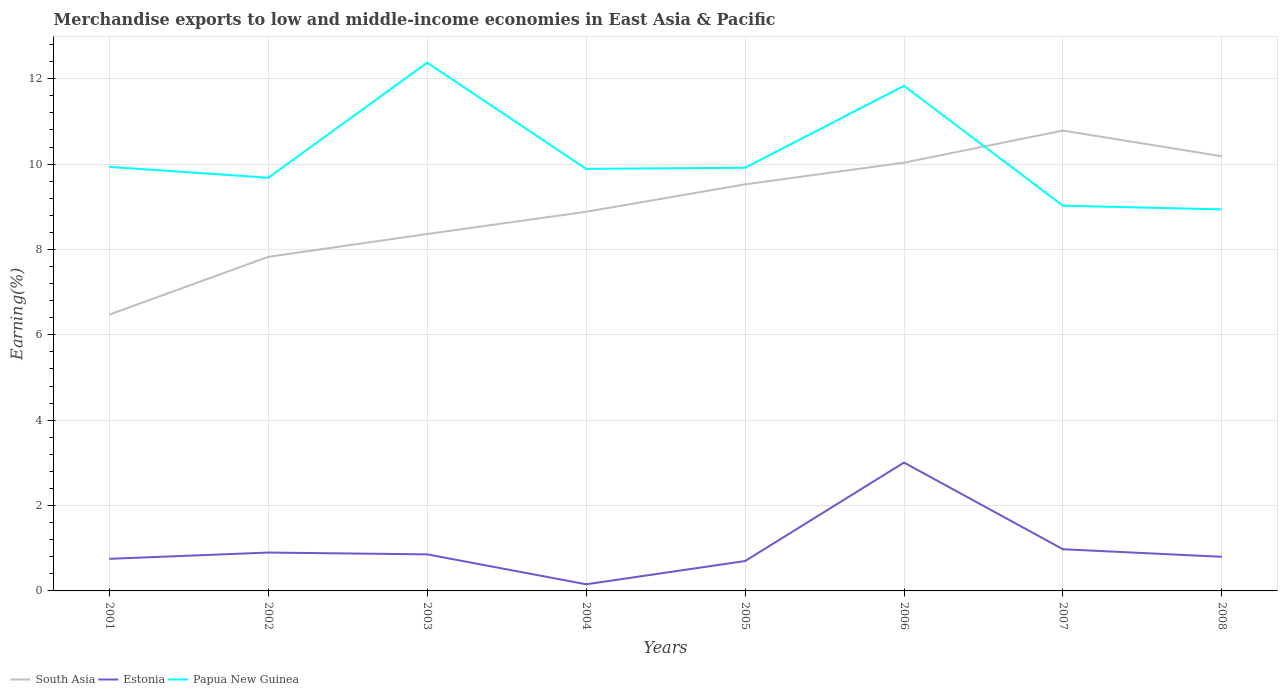Does the line corresponding to Estonia intersect with the line corresponding to South Asia?
Ensure brevity in your answer.  No. Is the number of lines equal to the number of legend labels?
Your answer should be compact. Yes. Across all years, what is the maximum percentage of amount earned from merchandise exports in South Asia?
Your answer should be very brief. 6.47. In which year was the percentage of amount earned from merchandise exports in Estonia maximum?
Your answer should be very brief. 2004. What is the total percentage of amount earned from merchandise exports in South Asia in the graph?
Give a very brief answer. -2.42. What is the difference between the highest and the second highest percentage of amount earned from merchandise exports in Papua New Guinea?
Your answer should be compact. 3.44. Is the percentage of amount earned from merchandise exports in Estonia strictly greater than the percentage of amount earned from merchandise exports in Papua New Guinea over the years?
Keep it short and to the point. Yes. How many lines are there?
Offer a very short reply. 3. Does the graph contain any zero values?
Provide a short and direct response. No. Does the graph contain grids?
Provide a succinct answer. Yes. Where does the legend appear in the graph?
Keep it short and to the point. Bottom left. How are the legend labels stacked?
Ensure brevity in your answer.  Horizontal. What is the title of the graph?
Offer a very short reply. Merchandise exports to low and middle-income economies in East Asia & Pacific. What is the label or title of the Y-axis?
Keep it short and to the point. Earning(%). What is the Earning(%) in South Asia in 2001?
Provide a short and direct response. 6.47. What is the Earning(%) in Estonia in 2001?
Give a very brief answer. 0.75. What is the Earning(%) of Papua New Guinea in 2001?
Provide a short and direct response. 9.94. What is the Earning(%) in South Asia in 2002?
Offer a very short reply. 7.83. What is the Earning(%) in Estonia in 2002?
Your response must be concise. 0.9. What is the Earning(%) in Papua New Guinea in 2002?
Your answer should be compact. 9.68. What is the Earning(%) of South Asia in 2003?
Your response must be concise. 8.36. What is the Earning(%) in Estonia in 2003?
Keep it short and to the point. 0.86. What is the Earning(%) in Papua New Guinea in 2003?
Make the answer very short. 12.38. What is the Earning(%) in South Asia in 2004?
Your answer should be very brief. 8.88. What is the Earning(%) in Estonia in 2004?
Offer a very short reply. 0.16. What is the Earning(%) of Papua New Guinea in 2004?
Keep it short and to the point. 9.89. What is the Earning(%) in South Asia in 2005?
Give a very brief answer. 9.53. What is the Earning(%) in Estonia in 2005?
Your answer should be compact. 0.7. What is the Earning(%) in Papua New Guinea in 2005?
Your answer should be very brief. 9.91. What is the Earning(%) of South Asia in 2006?
Your response must be concise. 10.03. What is the Earning(%) of Estonia in 2006?
Provide a succinct answer. 3.01. What is the Earning(%) in Papua New Guinea in 2006?
Provide a short and direct response. 11.83. What is the Earning(%) of South Asia in 2007?
Keep it short and to the point. 10.79. What is the Earning(%) in Estonia in 2007?
Ensure brevity in your answer.  0.98. What is the Earning(%) of Papua New Guinea in 2007?
Your response must be concise. 9.03. What is the Earning(%) of South Asia in 2008?
Your answer should be very brief. 10.18. What is the Earning(%) of Estonia in 2008?
Offer a terse response. 0.8. What is the Earning(%) of Papua New Guinea in 2008?
Make the answer very short. 8.94. Across all years, what is the maximum Earning(%) in South Asia?
Provide a succinct answer. 10.79. Across all years, what is the maximum Earning(%) of Estonia?
Keep it short and to the point. 3.01. Across all years, what is the maximum Earning(%) of Papua New Guinea?
Provide a short and direct response. 12.38. Across all years, what is the minimum Earning(%) in South Asia?
Provide a short and direct response. 6.47. Across all years, what is the minimum Earning(%) of Estonia?
Make the answer very short. 0.16. Across all years, what is the minimum Earning(%) of Papua New Guinea?
Offer a terse response. 8.94. What is the total Earning(%) of South Asia in the graph?
Provide a short and direct response. 72.07. What is the total Earning(%) in Estonia in the graph?
Ensure brevity in your answer.  8.15. What is the total Earning(%) in Papua New Guinea in the graph?
Keep it short and to the point. 81.59. What is the difference between the Earning(%) of South Asia in 2001 and that in 2002?
Provide a short and direct response. -1.35. What is the difference between the Earning(%) in Estonia in 2001 and that in 2002?
Your answer should be compact. -0.15. What is the difference between the Earning(%) in Papua New Guinea in 2001 and that in 2002?
Make the answer very short. 0.26. What is the difference between the Earning(%) in South Asia in 2001 and that in 2003?
Provide a succinct answer. -1.89. What is the difference between the Earning(%) in Estonia in 2001 and that in 2003?
Your answer should be very brief. -0.1. What is the difference between the Earning(%) in Papua New Guinea in 2001 and that in 2003?
Keep it short and to the point. -2.44. What is the difference between the Earning(%) in South Asia in 2001 and that in 2004?
Give a very brief answer. -2.41. What is the difference between the Earning(%) in Estonia in 2001 and that in 2004?
Your response must be concise. 0.6. What is the difference between the Earning(%) of Papua New Guinea in 2001 and that in 2004?
Make the answer very short. 0.05. What is the difference between the Earning(%) in South Asia in 2001 and that in 2005?
Offer a very short reply. -3.05. What is the difference between the Earning(%) of Estonia in 2001 and that in 2005?
Keep it short and to the point. 0.05. What is the difference between the Earning(%) in Papua New Guinea in 2001 and that in 2005?
Provide a succinct answer. 0.02. What is the difference between the Earning(%) in South Asia in 2001 and that in 2006?
Keep it short and to the point. -3.56. What is the difference between the Earning(%) in Estonia in 2001 and that in 2006?
Your answer should be compact. -2.26. What is the difference between the Earning(%) of Papua New Guinea in 2001 and that in 2006?
Offer a very short reply. -1.9. What is the difference between the Earning(%) of South Asia in 2001 and that in 2007?
Your answer should be compact. -4.31. What is the difference between the Earning(%) of Estonia in 2001 and that in 2007?
Give a very brief answer. -0.22. What is the difference between the Earning(%) of Papua New Guinea in 2001 and that in 2007?
Give a very brief answer. 0.91. What is the difference between the Earning(%) in South Asia in 2001 and that in 2008?
Make the answer very short. -3.71. What is the difference between the Earning(%) in Estonia in 2001 and that in 2008?
Provide a short and direct response. -0.05. What is the difference between the Earning(%) in South Asia in 2002 and that in 2003?
Your response must be concise. -0.54. What is the difference between the Earning(%) in Estonia in 2002 and that in 2003?
Your response must be concise. 0.04. What is the difference between the Earning(%) in Papua New Guinea in 2002 and that in 2003?
Your answer should be compact. -2.7. What is the difference between the Earning(%) in South Asia in 2002 and that in 2004?
Offer a very short reply. -1.06. What is the difference between the Earning(%) of Estonia in 2002 and that in 2004?
Give a very brief answer. 0.74. What is the difference between the Earning(%) of Papua New Guinea in 2002 and that in 2004?
Offer a terse response. -0.21. What is the difference between the Earning(%) of South Asia in 2002 and that in 2005?
Keep it short and to the point. -1.7. What is the difference between the Earning(%) of Estonia in 2002 and that in 2005?
Your answer should be very brief. 0.2. What is the difference between the Earning(%) in Papua New Guinea in 2002 and that in 2005?
Ensure brevity in your answer.  -0.23. What is the difference between the Earning(%) in South Asia in 2002 and that in 2006?
Keep it short and to the point. -2.21. What is the difference between the Earning(%) of Estonia in 2002 and that in 2006?
Your response must be concise. -2.11. What is the difference between the Earning(%) in Papua New Guinea in 2002 and that in 2006?
Keep it short and to the point. -2.15. What is the difference between the Earning(%) in South Asia in 2002 and that in 2007?
Give a very brief answer. -2.96. What is the difference between the Earning(%) in Estonia in 2002 and that in 2007?
Provide a succinct answer. -0.08. What is the difference between the Earning(%) of Papua New Guinea in 2002 and that in 2007?
Offer a very short reply. 0.65. What is the difference between the Earning(%) in South Asia in 2002 and that in 2008?
Your answer should be very brief. -2.36. What is the difference between the Earning(%) of Estonia in 2002 and that in 2008?
Make the answer very short. 0.1. What is the difference between the Earning(%) in Papua New Guinea in 2002 and that in 2008?
Your answer should be very brief. 0.74. What is the difference between the Earning(%) in South Asia in 2003 and that in 2004?
Provide a short and direct response. -0.52. What is the difference between the Earning(%) of Estonia in 2003 and that in 2004?
Ensure brevity in your answer.  0.7. What is the difference between the Earning(%) in Papua New Guinea in 2003 and that in 2004?
Offer a terse response. 2.49. What is the difference between the Earning(%) in South Asia in 2003 and that in 2005?
Your response must be concise. -1.16. What is the difference between the Earning(%) of Estonia in 2003 and that in 2005?
Offer a very short reply. 0.16. What is the difference between the Earning(%) of Papua New Guinea in 2003 and that in 2005?
Keep it short and to the point. 2.46. What is the difference between the Earning(%) in South Asia in 2003 and that in 2006?
Provide a succinct answer. -1.67. What is the difference between the Earning(%) of Estonia in 2003 and that in 2006?
Keep it short and to the point. -2.15. What is the difference between the Earning(%) in Papua New Guinea in 2003 and that in 2006?
Keep it short and to the point. 0.54. What is the difference between the Earning(%) in South Asia in 2003 and that in 2007?
Your response must be concise. -2.42. What is the difference between the Earning(%) in Estonia in 2003 and that in 2007?
Provide a short and direct response. -0.12. What is the difference between the Earning(%) of Papua New Guinea in 2003 and that in 2007?
Your response must be concise. 3.35. What is the difference between the Earning(%) of South Asia in 2003 and that in 2008?
Keep it short and to the point. -1.82. What is the difference between the Earning(%) in Estonia in 2003 and that in 2008?
Make the answer very short. 0.06. What is the difference between the Earning(%) in Papua New Guinea in 2003 and that in 2008?
Provide a short and direct response. 3.44. What is the difference between the Earning(%) in South Asia in 2004 and that in 2005?
Offer a terse response. -0.64. What is the difference between the Earning(%) in Estonia in 2004 and that in 2005?
Make the answer very short. -0.54. What is the difference between the Earning(%) of Papua New Guinea in 2004 and that in 2005?
Keep it short and to the point. -0.03. What is the difference between the Earning(%) of South Asia in 2004 and that in 2006?
Your answer should be compact. -1.15. What is the difference between the Earning(%) of Estonia in 2004 and that in 2006?
Make the answer very short. -2.85. What is the difference between the Earning(%) of Papua New Guinea in 2004 and that in 2006?
Keep it short and to the point. -1.95. What is the difference between the Earning(%) of South Asia in 2004 and that in 2007?
Give a very brief answer. -1.9. What is the difference between the Earning(%) in Estonia in 2004 and that in 2007?
Offer a very short reply. -0.82. What is the difference between the Earning(%) of Papua New Guinea in 2004 and that in 2007?
Provide a succinct answer. 0.86. What is the difference between the Earning(%) of South Asia in 2004 and that in 2008?
Offer a very short reply. -1.3. What is the difference between the Earning(%) of Estonia in 2004 and that in 2008?
Your response must be concise. -0.64. What is the difference between the Earning(%) in Papua New Guinea in 2004 and that in 2008?
Give a very brief answer. 0.95. What is the difference between the Earning(%) in South Asia in 2005 and that in 2006?
Give a very brief answer. -0.51. What is the difference between the Earning(%) of Estonia in 2005 and that in 2006?
Provide a succinct answer. -2.31. What is the difference between the Earning(%) in Papua New Guinea in 2005 and that in 2006?
Offer a very short reply. -1.92. What is the difference between the Earning(%) of South Asia in 2005 and that in 2007?
Your response must be concise. -1.26. What is the difference between the Earning(%) in Estonia in 2005 and that in 2007?
Make the answer very short. -0.28. What is the difference between the Earning(%) in Papua New Guinea in 2005 and that in 2007?
Give a very brief answer. 0.89. What is the difference between the Earning(%) of South Asia in 2005 and that in 2008?
Provide a short and direct response. -0.66. What is the difference between the Earning(%) of Estonia in 2005 and that in 2008?
Provide a succinct answer. -0.1. What is the difference between the Earning(%) of Papua New Guinea in 2005 and that in 2008?
Provide a short and direct response. 0.98. What is the difference between the Earning(%) of South Asia in 2006 and that in 2007?
Your answer should be compact. -0.75. What is the difference between the Earning(%) of Estonia in 2006 and that in 2007?
Your answer should be compact. 2.03. What is the difference between the Earning(%) in Papua New Guinea in 2006 and that in 2007?
Your answer should be very brief. 2.81. What is the difference between the Earning(%) of South Asia in 2006 and that in 2008?
Make the answer very short. -0.15. What is the difference between the Earning(%) of Estonia in 2006 and that in 2008?
Make the answer very short. 2.21. What is the difference between the Earning(%) of Papua New Guinea in 2006 and that in 2008?
Provide a short and direct response. 2.89. What is the difference between the Earning(%) in South Asia in 2007 and that in 2008?
Keep it short and to the point. 0.6. What is the difference between the Earning(%) in Estonia in 2007 and that in 2008?
Your answer should be very brief. 0.18. What is the difference between the Earning(%) in Papua New Guinea in 2007 and that in 2008?
Provide a short and direct response. 0.09. What is the difference between the Earning(%) of South Asia in 2001 and the Earning(%) of Estonia in 2002?
Your answer should be compact. 5.57. What is the difference between the Earning(%) in South Asia in 2001 and the Earning(%) in Papua New Guinea in 2002?
Your answer should be compact. -3.21. What is the difference between the Earning(%) of Estonia in 2001 and the Earning(%) of Papua New Guinea in 2002?
Provide a succinct answer. -8.93. What is the difference between the Earning(%) in South Asia in 2001 and the Earning(%) in Estonia in 2003?
Keep it short and to the point. 5.62. What is the difference between the Earning(%) of South Asia in 2001 and the Earning(%) of Papua New Guinea in 2003?
Provide a short and direct response. -5.9. What is the difference between the Earning(%) in Estonia in 2001 and the Earning(%) in Papua New Guinea in 2003?
Offer a very short reply. -11.62. What is the difference between the Earning(%) in South Asia in 2001 and the Earning(%) in Estonia in 2004?
Provide a short and direct response. 6.32. What is the difference between the Earning(%) in South Asia in 2001 and the Earning(%) in Papua New Guinea in 2004?
Give a very brief answer. -3.42. What is the difference between the Earning(%) in Estonia in 2001 and the Earning(%) in Papua New Guinea in 2004?
Make the answer very short. -9.14. What is the difference between the Earning(%) of South Asia in 2001 and the Earning(%) of Estonia in 2005?
Provide a succinct answer. 5.77. What is the difference between the Earning(%) in South Asia in 2001 and the Earning(%) in Papua New Guinea in 2005?
Ensure brevity in your answer.  -3.44. What is the difference between the Earning(%) of Estonia in 2001 and the Earning(%) of Papua New Guinea in 2005?
Make the answer very short. -9.16. What is the difference between the Earning(%) of South Asia in 2001 and the Earning(%) of Estonia in 2006?
Give a very brief answer. 3.47. What is the difference between the Earning(%) in South Asia in 2001 and the Earning(%) in Papua New Guinea in 2006?
Your answer should be very brief. -5.36. What is the difference between the Earning(%) of Estonia in 2001 and the Earning(%) of Papua New Guinea in 2006?
Your answer should be compact. -11.08. What is the difference between the Earning(%) of South Asia in 2001 and the Earning(%) of Estonia in 2007?
Provide a short and direct response. 5.5. What is the difference between the Earning(%) of South Asia in 2001 and the Earning(%) of Papua New Guinea in 2007?
Make the answer very short. -2.55. What is the difference between the Earning(%) in Estonia in 2001 and the Earning(%) in Papua New Guinea in 2007?
Provide a succinct answer. -8.27. What is the difference between the Earning(%) of South Asia in 2001 and the Earning(%) of Estonia in 2008?
Offer a terse response. 5.67. What is the difference between the Earning(%) in South Asia in 2001 and the Earning(%) in Papua New Guinea in 2008?
Provide a succinct answer. -2.47. What is the difference between the Earning(%) in Estonia in 2001 and the Earning(%) in Papua New Guinea in 2008?
Offer a terse response. -8.19. What is the difference between the Earning(%) of South Asia in 2002 and the Earning(%) of Estonia in 2003?
Make the answer very short. 6.97. What is the difference between the Earning(%) of South Asia in 2002 and the Earning(%) of Papua New Guinea in 2003?
Give a very brief answer. -4.55. What is the difference between the Earning(%) of Estonia in 2002 and the Earning(%) of Papua New Guinea in 2003?
Provide a short and direct response. -11.48. What is the difference between the Earning(%) of South Asia in 2002 and the Earning(%) of Estonia in 2004?
Offer a very short reply. 7.67. What is the difference between the Earning(%) in South Asia in 2002 and the Earning(%) in Papua New Guinea in 2004?
Offer a terse response. -2.06. What is the difference between the Earning(%) of Estonia in 2002 and the Earning(%) of Papua New Guinea in 2004?
Make the answer very short. -8.99. What is the difference between the Earning(%) in South Asia in 2002 and the Earning(%) in Estonia in 2005?
Keep it short and to the point. 7.13. What is the difference between the Earning(%) of South Asia in 2002 and the Earning(%) of Papua New Guinea in 2005?
Your answer should be very brief. -2.09. What is the difference between the Earning(%) of Estonia in 2002 and the Earning(%) of Papua New Guinea in 2005?
Your response must be concise. -9.02. What is the difference between the Earning(%) of South Asia in 2002 and the Earning(%) of Estonia in 2006?
Your response must be concise. 4.82. What is the difference between the Earning(%) in South Asia in 2002 and the Earning(%) in Papua New Guinea in 2006?
Offer a very short reply. -4.01. What is the difference between the Earning(%) of Estonia in 2002 and the Earning(%) of Papua New Guinea in 2006?
Provide a succinct answer. -10.93. What is the difference between the Earning(%) of South Asia in 2002 and the Earning(%) of Estonia in 2007?
Ensure brevity in your answer.  6.85. What is the difference between the Earning(%) in South Asia in 2002 and the Earning(%) in Papua New Guinea in 2007?
Ensure brevity in your answer.  -1.2. What is the difference between the Earning(%) of Estonia in 2002 and the Earning(%) of Papua New Guinea in 2007?
Keep it short and to the point. -8.13. What is the difference between the Earning(%) of South Asia in 2002 and the Earning(%) of Estonia in 2008?
Keep it short and to the point. 7.03. What is the difference between the Earning(%) in South Asia in 2002 and the Earning(%) in Papua New Guinea in 2008?
Offer a very short reply. -1.11. What is the difference between the Earning(%) of Estonia in 2002 and the Earning(%) of Papua New Guinea in 2008?
Your response must be concise. -8.04. What is the difference between the Earning(%) in South Asia in 2003 and the Earning(%) in Estonia in 2004?
Give a very brief answer. 8.21. What is the difference between the Earning(%) in South Asia in 2003 and the Earning(%) in Papua New Guinea in 2004?
Provide a short and direct response. -1.53. What is the difference between the Earning(%) in Estonia in 2003 and the Earning(%) in Papua New Guinea in 2004?
Your answer should be very brief. -9.03. What is the difference between the Earning(%) of South Asia in 2003 and the Earning(%) of Estonia in 2005?
Your response must be concise. 7.66. What is the difference between the Earning(%) of South Asia in 2003 and the Earning(%) of Papua New Guinea in 2005?
Your answer should be compact. -1.55. What is the difference between the Earning(%) of Estonia in 2003 and the Earning(%) of Papua New Guinea in 2005?
Offer a very short reply. -9.06. What is the difference between the Earning(%) in South Asia in 2003 and the Earning(%) in Estonia in 2006?
Your answer should be compact. 5.36. What is the difference between the Earning(%) in South Asia in 2003 and the Earning(%) in Papua New Guinea in 2006?
Provide a succinct answer. -3.47. What is the difference between the Earning(%) of Estonia in 2003 and the Earning(%) of Papua New Guinea in 2006?
Offer a very short reply. -10.98. What is the difference between the Earning(%) in South Asia in 2003 and the Earning(%) in Estonia in 2007?
Your answer should be very brief. 7.39. What is the difference between the Earning(%) in South Asia in 2003 and the Earning(%) in Papua New Guinea in 2007?
Make the answer very short. -0.66. What is the difference between the Earning(%) in Estonia in 2003 and the Earning(%) in Papua New Guinea in 2007?
Your answer should be very brief. -8.17. What is the difference between the Earning(%) in South Asia in 2003 and the Earning(%) in Estonia in 2008?
Your response must be concise. 7.56. What is the difference between the Earning(%) in South Asia in 2003 and the Earning(%) in Papua New Guinea in 2008?
Your answer should be compact. -0.58. What is the difference between the Earning(%) in Estonia in 2003 and the Earning(%) in Papua New Guinea in 2008?
Make the answer very short. -8.08. What is the difference between the Earning(%) of South Asia in 2004 and the Earning(%) of Estonia in 2005?
Make the answer very short. 8.18. What is the difference between the Earning(%) of South Asia in 2004 and the Earning(%) of Papua New Guinea in 2005?
Provide a short and direct response. -1.03. What is the difference between the Earning(%) of Estonia in 2004 and the Earning(%) of Papua New Guinea in 2005?
Offer a terse response. -9.76. What is the difference between the Earning(%) in South Asia in 2004 and the Earning(%) in Estonia in 2006?
Keep it short and to the point. 5.88. What is the difference between the Earning(%) of South Asia in 2004 and the Earning(%) of Papua New Guinea in 2006?
Your answer should be very brief. -2.95. What is the difference between the Earning(%) in Estonia in 2004 and the Earning(%) in Papua New Guinea in 2006?
Make the answer very short. -11.68. What is the difference between the Earning(%) in South Asia in 2004 and the Earning(%) in Estonia in 2007?
Give a very brief answer. 7.91. What is the difference between the Earning(%) in South Asia in 2004 and the Earning(%) in Papua New Guinea in 2007?
Offer a very short reply. -0.14. What is the difference between the Earning(%) of Estonia in 2004 and the Earning(%) of Papua New Guinea in 2007?
Ensure brevity in your answer.  -8.87. What is the difference between the Earning(%) of South Asia in 2004 and the Earning(%) of Estonia in 2008?
Your response must be concise. 8.08. What is the difference between the Earning(%) in South Asia in 2004 and the Earning(%) in Papua New Guinea in 2008?
Provide a succinct answer. -0.06. What is the difference between the Earning(%) in Estonia in 2004 and the Earning(%) in Papua New Guinea in 2008?
Provide a succinct answer. -8.78. What is the difference between the Earning(%) in South Asia in 2005 and the Earning(%) in Estonia in 2006?
Make the answer very short. 6.52. What is the difference between the Earning(%) of South Asia in 2005 and the Earning(%) of Papua New Guinea in 2006?
Keep it short and to the point. -2.31. What is the difference between the Earning(%) in Estonia in 2005 and the Earning(%) in Papua New Guinea in 2006?
Make the answer very short. -11.13. What is the difference between the Earning(%) of South Asia in 2005 and the Earning(%) of Estonia in 2007?
Your answer should be compact. 8.55. What is the difference between the Earning(%) in South Asia in 2005 and the Earning(%) in Papua New Guinea in 2007?
Offer a terse response. 0.5. What is the difference between the Earning(%) of Estonia in 2005 and the Earning(%) of Papua New Guinea in 2007?
Provide a succinct answer. -8.33. What is the difference between the Earning(%) of South Asia in 2005 and the Earning(%) of Estonia in 2008?
Keep it short and to the point. 8.73. What is the difference between the Earning(%) in South Asia in 2005 and the Earning(%) in Papua New Guinea in 2008?
Your answer should be compact. 0.59. What is the difference between the Earning(%) of Estonia in 2005 and the Earning(%) of Papua New Guinea in 2008?
Provide a succinct answer. -8.24. What is the difference between the Earning(%) in South Asia in 2006 and the Earning(%) in Estonia in 2007?
Make the answer very short. 9.06. What is the difference between the Earning(%) of South Asia in 2006 and the Earning(%) of Papua New Guinea in 2007?
Provide a short and direct response. 1.01. What is the difference between the Earning(%) of Estonia in 2006 and the Earning(%) of Papua New Guinea in 2007?
Make the answer very short. -6.02. What is the difference between the Earning(%) in South Asia in 2006 and the Earning(%) in Estonia in 2008?
Keep it short and to the point. 9.23. What is the difference between the Earning(%) in South Asia in 2006 and the Earning(%) in Papua New Guinea in 2008?
Provide a short and direct response. 1.09. What is the difference between the Earning(%) in Estonia in 2006 and the Earning(%) in Papua New Guinea in 2008?
Offer a terse response. -5.93. What is the difference between the Earning(%) in South Asia in 2007 and the Earning(%) in Estonia in 2008?
Make the answer very short. 9.99. What is the difference between the Earning(%) in South Asia in 2007 and the Earning(%) in Papua New Guinea in 2008?
Provide a succinct answer. 1.85. What is the difference between the Earning(%) of Estonia in 2007 and the Earning(%) of Papua New Guinea in 2008?
Your response must be concise. -7.96. What is the average Earning(%) of South Asia per year?
Provide a short and direct response. 9.01. What is the average Earning(%) in Estonia per year?
Ensure brevity in your answer.  1.02. What is the average Earning(%) in Papua New Guinea per year?
Provide a succinct answer. 10.2. In the year 2001, what is the difference between the Earning(%) in South Asia and Earning(%) in Estonia?
Provide a succinct answer. 5.72. In the year 2001, what is the difference between the Earning(%) of South Asia and Earning(%) of Papua New Guinea?
Ensure brevity in your answer.  -3.46. In the year 2001, what is the difference between the Earning(%) in Estonia and Earning(%) in Papua New Guinea?
Offer a very short reply. -9.18. In the year 2002, what is the difference between the Earning(%) of South Asia and Earning(%) of Estonia?
Your answer should be compact. 6.93. In the year 2002, what is the difference between the Earning(%) of South Asia and Earning(%) of Papua New Guinea?
Offer a terse response. -1.85. In the year 2002, what is the difference between the Earning(%) of Estonia and Earning(%) of Papua New Guinea?
Your answer should be very brief. -8.78. In the year 2003, what is the difference between the Earning(%) in South Asia and Earning(%) in Estonia?
Ensure brevity in your answer.  7.51. In the year 2003, what is the difference between the Earning(%) in South Asia and Earning(%) in Papua New Guinea?
Your response must be concise. -4.01. In the year 2003, what is the difference between the Earning(%) in Estonia and Earning(%) in Papua New Guinea?
Provide a short and direct response. -11.52. In the year 2004, what is the difference between the Earning(%) of South Asia and Earning(%) of Estonia?
Offer a very short reply. 8.73. In the year 2004, what is the difference between the Earning(%) of South Asia and Earning(%) of Papua New Guinea?
Make the answer very short. -1.01. In the year 2004, what is the difference between the Earning(%) in Estonia and Earning(%) in Papua New Guinea?
Ensure brevity in your answer.  -9.73. In the year 2005, what is the difference between the Earning(%) of South Asia and Earning(%) of Estonia?
Keep it short and to the point. 8.83. In the year 2005, what is the difference between the Earning(%) in South Asia and Earning(%) in Papua New Guinea?
Offer a very short reply. -0.39. In the year 2005, what is the difference between the Earning(%) in Estonia and Earning(%) in Papua New Guinea?
Make the answer very short. -9.21. In the year 2006, what is the difference between the Earning(%) of South Asia and Earning(%) of Estonia?
Ensure brevity in your answer.  7.03. In the year 2006, what is the difference between the Earning(%) in Estonia and Earning(%) in Papua New Guinea?
Your answer should be compact. -8.83. In the year 2007, what is the difference between the Earning(%) in South Asia and Earning(%) in Estonia?
Make the answer very short. 9.81. In the year 2007, what is the difference between the Earning(%) of South Asia and Earning(%) of Papua New Guinea?
Your answer should be very brief. 1.76. In the year 2007, what is the difference between the Earning(%) of Estonia and Earning(%) of Papua New Guinea?
Give a very brief answer. -8.05. In the year 2008, what is the difference between the Earning(%) of South Asia and Earning(%) of Estonia?
Ensure brevity in your answer.  9.38. In the year 2008, what is the difference between the Earning(%) of South Asia and Earning(%) of Papua New Guinea?
Ensure brevity in your answer.  1.24. In the year 2008, what is the difference between the Earning(%) in Estonia and Earning(%) in Papua New Guinea?
Give a very brief answer. -8.14. What is the ratio of the Earning(%) in South Asia in 2001 to that in 2002?
Give a very brief answer. 0.83. What is the ratio of the Earning(%) of Estonia in 2001 to that in 2002?
Provide a short and direct response. 0.84. What is the ratio of the Earning(%) of Papua New Guinea in 2001 to that in 2002?
Provide a short and direct response. 1.03. What is the ratio of the Earning(%) of South Asia in 2001 to that in 2003?
Provide a succinct answer. 0.77. What is the ratio of the Earning(%) in Estonia in 2001 to that in 2003?
Keep it short and to the point. 0.88. What is the ratio of the Earning(%) in Papua New Guinea in 2001 to that in 2003?
Provide a short and direct response. 0.8. What is the ratio of the Earning(%) in South Asia in 2001 to that in 2004?
Offer a terse response. 0.73. What is the ratio of the Earning(%) in Estonia in 2001 to that in 2004?
Provide a short and direct response. 4.84. What is the ratio of the Earning(%) in Papua New Guinea in 2001 to that in 2004?
Keep it short and to the point. 1. What is the ratio of the Earning(%) of South Asia in 2001 to that in 2005?
Offer a terse response. 0.68. What is the ratio of the Earning(%) of Estonia in 2001 to that in 2005?
Ensure brevity in your answer.  1.07. What is the ratio of the Earning(%) of South Asia in 2001 to that in 2006?
Your answer should be compact. 0.65. What is the ratio of the Earning(%) in Estonia in 2001 to that in 2006?
Your response must be concise. 0.25. What is the ratio of the Earning(%) of Papua New Guinea in 2001 to that in 2006?
Your response must be concise. 0.84. What is the ratio of the Earning(%) in South Asia in 2001 to that in 2007?
Your response must be concise. 0.6. What is the ratio of the Earning(%) in Estonia in 2001 to that in 2007?
Make the answer very short. 0.77. What is the ratio of the Earning(%) in Papua New Guinea in 2001 to that in 2007?
Your answer should be very brief. 1.1. What is the ratio of the Earning(%) in South Asia in 2001 to that in 2008?
Provide a short and direct response. 0.64. What is the ratio of the Earning(%) in Estonia in 2001 to that in 2008?
Your answer should be very brief. 0.94. What is the ratio of the Earning(%) in Papua New Guinea in 2001 to that in 2008?
Give a very brief answer. 1.11. What is the ratio of the Earning(%) in South Asia in 2002 to that in 2003?
Keep it short and to the point. 0.94. What is the ratio of the Earning(%) of Estonia in 2002 to that in 2003?
Offer a very short reply. 1.05. What is the ratio of the Earning(%) in Papua New Guinea in 2002 to that in 2003?
Make the answer very short. 0.78. What is the ratio of the Earning(%) in South Asia in 2002 to that in 2004?
Ensure brevity in your answer.  0.88. What is the ratio of the Earning(%) in Estonia in 2002 to that in 2004?
Your response must be concise. 5.78. What is the ratio of the Earning(%) in Papua New Guinea in 2002 to that in 2004?
Ensure brevity in your answer.  0.98. What is the ratio of the Earning(%) of South Asia in 2002 to that in 2005?
Offer a terse response. 0.82. What is the ratio of the Earning(%) of Estonia in 2002 to that in 2005?
Ensure brevity in your answer.  1.28. What is the ratio of the Earning(%) of Papua New Guinea in 2002 to that in 2005?
Make the answer very short. 0.98. What is the ratio of the Earning(%) in South Asia in 2002 to that in 2006?
Keep it short and to the point. 0.78. What is the ratio of the Earning(%) of Estonia in 2002 to that in 2006?
Offer a terse response. 0.3. What is the ratio of the Earning(%) of Papua New Guinea in 2002 to that in 2006?
Your response must be concise. 0.82. What is the ratio of the Earning(%) of South Asia in 2002 to that in 2007?
Your answer should be very brief. 0.73. What is the ratio of the Earning(%) in Estonia in 2002 to that in 2007?
Give a very brief answer. 0.92. What is the ratio of the Earning(%) in Papua New Guinea in 2002 to that in 2007?
Give a very brief answer. 1.07. What is the ratio of the Earning(%) in South Asia in 2002 to that in 2008?
Make the answer very short. 0.77. What is the ratio of the Earning(%) in Estonia in 2002 to that in 2008?
Offer a very short reply. 1.12. What is the ratio of the Earning(%) of Papua New Guinea in 2002 to that in 2008?
Your answer should be compact. 1.08. What is the ratio of the Earning(%) in South Asia in 2003 to that in 2004?
Your answer should be compact. 0.94. What is the ratio of the Earning(%) of Estonia in 2003 to that in 2004?
Offer a very short reply. 5.51. What is the ratio of the Earning(%) of Papua New Guinea in 2003 to that in 2004?
Provide a short and direct response. 1.25. What is the ratio of the Earning(%) of South Asia in 2003 to that in 2005?
Ensure brevity in your answer.  0.88. What is the ratio of the Earning(%) in Estonia in 2003 to that in 2005?
Keep it short and to the point. 1.22. What is the ratio of the Earning(%) in Papua New Guinea in 2003 to that in 2005?
Ensure brevity in your answer.  1.25. What is the ratio of the Earning(%) in South Asia in 2003 to that in 2006?
Make the answer very short. 0.83. What is the ratio of the Earning(%) in Estonia in 2003 to that in 2006?
Keep it short and to the point. 0.28. What is the ratio of the Earning(%) of Papua New Guinea in 2003 to that in 2006?
Provide a succinct answer. 1.05. What is the ratio of the Earning(%) of South Asia in 2003 to that in 2007?
Provide a short and direct response. 0.78. What is the ratio of the Earning(%) in Estonia in 2003 to that in 2007?
Your answer should be compact. 0.88. What is the ratio of the Earning(%) in Papua New Guinea in 2003 to that in 2007?
Offer a terse response. 1.37. What is the ratio of the Earning(%) of South Asia in 2003 to that in 2008?
Ensure brevity in your answer.  0.82. What is the ratio of the Earning(%) of Estonia in 2003 to that in 2008?
Ensure brevity in your answer.  1.07. What is the ratio of the Earning(%) in Papua New Guinea in 2003 to that in 2008?
Your answer should be very brief. 1.38. What is the ratio of the Earning(%) of South Asia in 2004 to that in 2005?
Offer a terse response. 0.93. What is the ratio of the Earning(%) of Estonia in 2004 to that in 2005?
Give a very brief answer. 0.22. What is the ratio of the Earning(%) of Papua New Guinea in 2004 to that in 2005?
Provide a short and direct response. 1. What is the ratio of the Earning(%) in South Asia in 2004 to that in 2006?
Keep it short and to the point. 0.89. What is the ratio of the Earning(%) of Estonia in 2004 to that in 2006?
Your answer should be compact. 0.05. What is the ratio of the Earning(%) of Papua New Guinea in 2004 to that in 2006?
Keep it short and to the point. 0.84. What is the ratio of the Earning(%) of South Asia in 2004 to that in 2007?
Ensure brevity in your answer.  0.82. What is the ratio of the Earning(%) of Estonia in 2004 to that in 2007?
Offer a very short reply. 0.16. What is the ratio of the Earning(%) of Papua New Guinea in 2004 to that in 2007?
Keep it short and to the point. 1.1. What is the ratio of the Earning(%) in South Asia in 2004 to that in 2008?
Ensure brevity in your answer.  0.87. What is the ratio of the Earning(%) in Estonia in 2004 to that in 2008?
Your answer should be very brief. 0.19. What is the ratio of the Earning(%) of Papua New Guinea in 2004 to that in 2008?
Your answer should be very brief. 1.11. What is the ratio of the Earning(%) in South Asia in 2005 to that in 2006?
Your answer should be compact. 0.95. What is the ratio of the Earning(%) in Estonia in 2005 to that in 2006?
Offer a very short reply. 0.23. What is the ratio of the Earning(%) in Papua New Guinea in 2005 to that in 2006?
Give a very brief answer. 0.84. What is the ratio of the Earning(%) in South Asia in 2005 to that in 2007?
Offer a terse response. 0.88. What is the ratio of the Earning(%) of Estonia in 2005 to that in 2007?
Your answer should be very brief. 0.72. What is the ratio of the Earning(%) of Papua New Guinea in 2005 to that in 2007?
Keep it short and to the point. 1.1. What is the ratio of the Earning(%) of South Asia in 2005 to that in 2008?
Provide a succinct answer. 0.94. What is the ratio of the Earning(%) in Estonia in 2005 to that in 2008?
Give a very brief answer. 0.88. What is the ratio of the Earning(%) in Papua New Guinea in 2005 to that in 2008?
Keep it short and to the point. 1.11. What is the ratio of the Earning(%) in South Asia in 2006 to that in 2007?
Make the answer very short. 0.93. What is the ratio of the Earning(%) in Estonia in 2006 to that in 2007?
Ensure brevity in your answer.  3.08. What is the ratio of the Earning(%) of Papua New Guinea in 2006 to that in 2007?
Your answer should be compact. 1.31. What is the ratio of the Earning(%) in South Asia in 2006 to that in 2008?
Provide a succinct answer. 0.99. What is the ratio of the Earning(%) in Estonia in 2006 to that in 2008?
Keep it short and to the point. 3.76. What is the ratio of the Earning(%) of Papua New Guinea in 2006 to that in 2008?
Ensure brevity in your answer.  1.32. What is the ratio of the Earning(%) in South Asia in 2007 to that in 2008?
Offer a terse response. 1.06. What is the ratio of the Earning(%) of Estonia in 2007 to that in 2008?
Provide a short and direct response. 1.22. What is the ratio of the Earning(%) of Papua New Guinea in 2007 to that in 2008?
Provide a succinct answer. 1.01. What is the difference between the highest and the second highest Earning(%) of South Asia?
Ensure brevity in your answer.  0.6. What is the difference between the highest and the second highest Earning(%) of Estonia?
Keep it short and to the point. 2.03. What is the difference between the highest and the second highest Earning(%) in Papua New Guinea?
Make the answer very short. 0.54. What is the difference between the highest and the lowest Earning(%) in South Asia?
Your answer should be very brief. 4.31. What is the difference between the highest and the lowest Earning(%) in Estonia?
Make the answer very short. 2.85. What is the difference between the highest and the lowest Earning(%) in Papua New Guinea?
Your answer should be very brief. 3.44. 